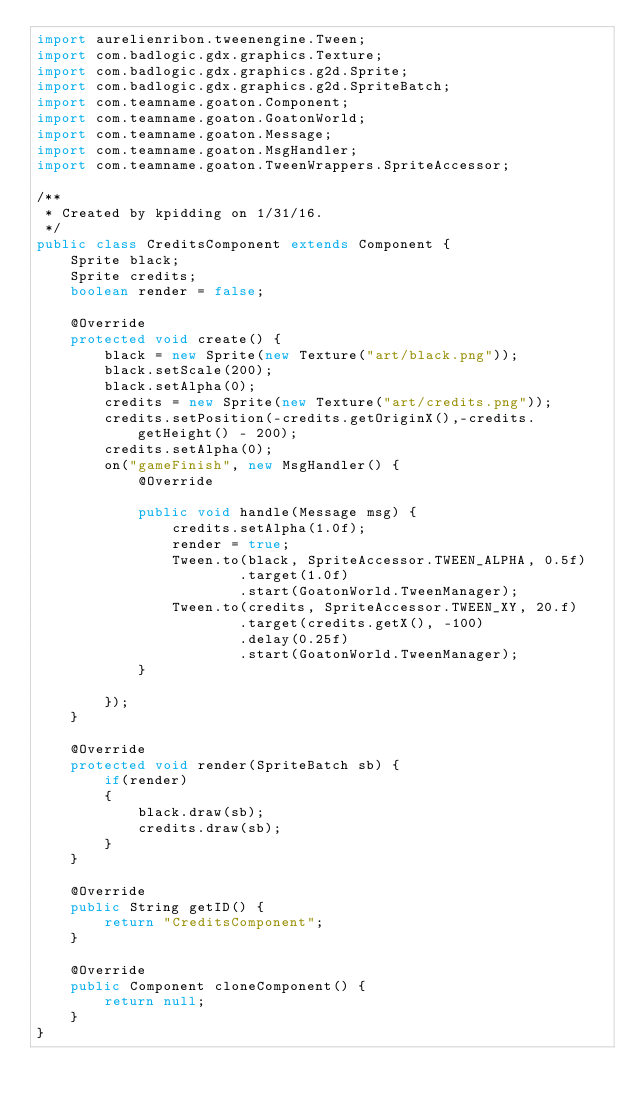<code> <loc_0><loc_0><loc_500><loc_500><_Java_>import aurelienribon.tweenengine.Tween;
import com.badlogic.gdx.graphics.Texture;
import com.badlogic.gdx.graphics.g2d.Sprite;
import com.badlogic.gdx.graphics.g2d.SpriteBatch;
import com.teamname.goaton.Component;
import com.teamname.goaton.GoatonWorld;
import com.teamname.goaton.Message;
import com.teamname.goaton.MsgHandler;
import com.teamname.goaton.TweenWrappers.SpriteAccessor;

/**
 * Created by kpidding on 1/31/16.
 */
public class CreditsComponent extends Component {
    Sprite black;
    Sprite credits;
    boolean render = false;

    @Override
    protected void create() {
        black = new Sprite(new Texture("art/black.png"));
        black.setScale(200);
        black.setAlpha(0);
        credits = new Sprite(new Texture("art/credits.png"));
        credits.setPosition(-credits.getOriginX(),-credits.getHeight() - 200);
        credits.setAlpha(0);
        on("gameFinish", new MsgHandler() {
            @Override

            public void handle(Message msg) {
                credits.setAlpha(1.0f);
                render = true;
                Tween.to(black, SpriteAccessor.TWEEN_ALPHA, 0.5f)
                        .target(1.0f)
                        .start(GoatonWorld.TweenManager);
                Tween.to(credits, SpriteAccessor.TWEEN_XY, 20.f)
                        .target(credits.getX(), -100)
                        .delay(0.25f)
                        .start(GoatonWorld.TweenManager);
            }

        });
    }

    @Override
    protected void render(SpriteBatch sb) {
        if(render)
        {
            black.draw(sb);
            credits.draw(sb);
        }
    }

    @Override
    public String getID() {
        return "CreditsComponent";
    }

    @Override
    public Component cloneComponent() {
        return null;
    }
}
</code> 